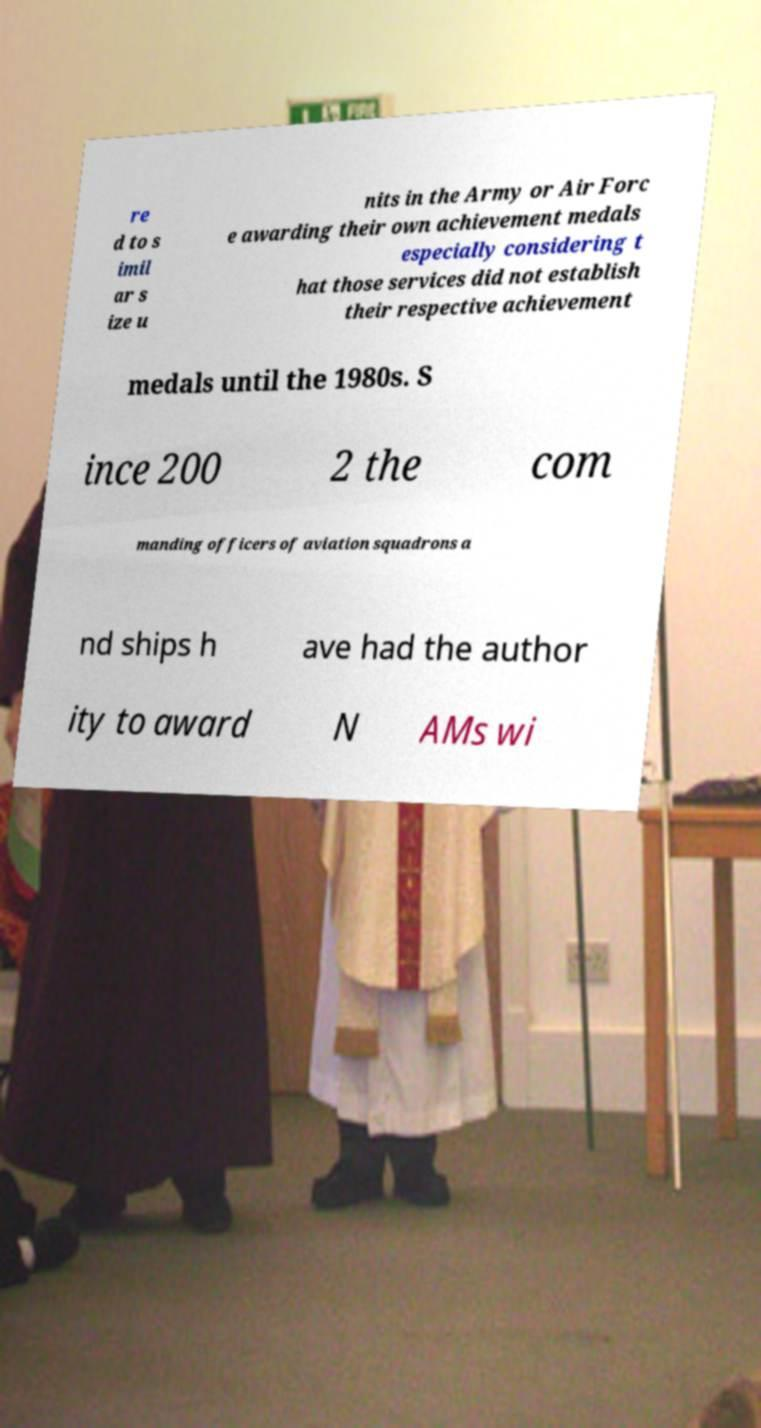Can you read and provide the text displayed in the image?This photo seems to have some interesting text. Can you extract and type it out for me? re d to s imil ar s ize u nits in the Army or Air Forc e awarding their own achievement medals especially considering t hat those services did not establish their respective achievement medals until the 1980s. S ince 200 2 the com manding officers of aviation squadrons a nd ships h ave had the author ity to award N AMs wi 